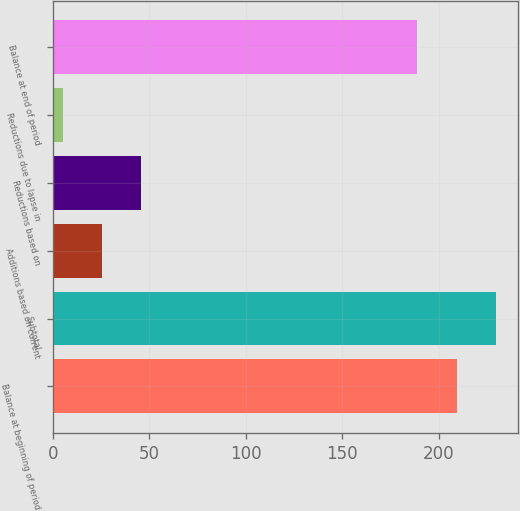Convert chart. <chart><loc_0><loc_0><loc_500><loc_500><bar_chart><fcel>Balance at beginning of period<fcel>Subtotal<fcel>Additions based on current<fcel>Reductions based on<fcel>Reductions due to lapse in<fcel>Balance at end of period<nl><fcel>209.4<fcel>229.8<fcel>25.4<fcel>45.8<fcel>5<fcel>189<nl></chart> 